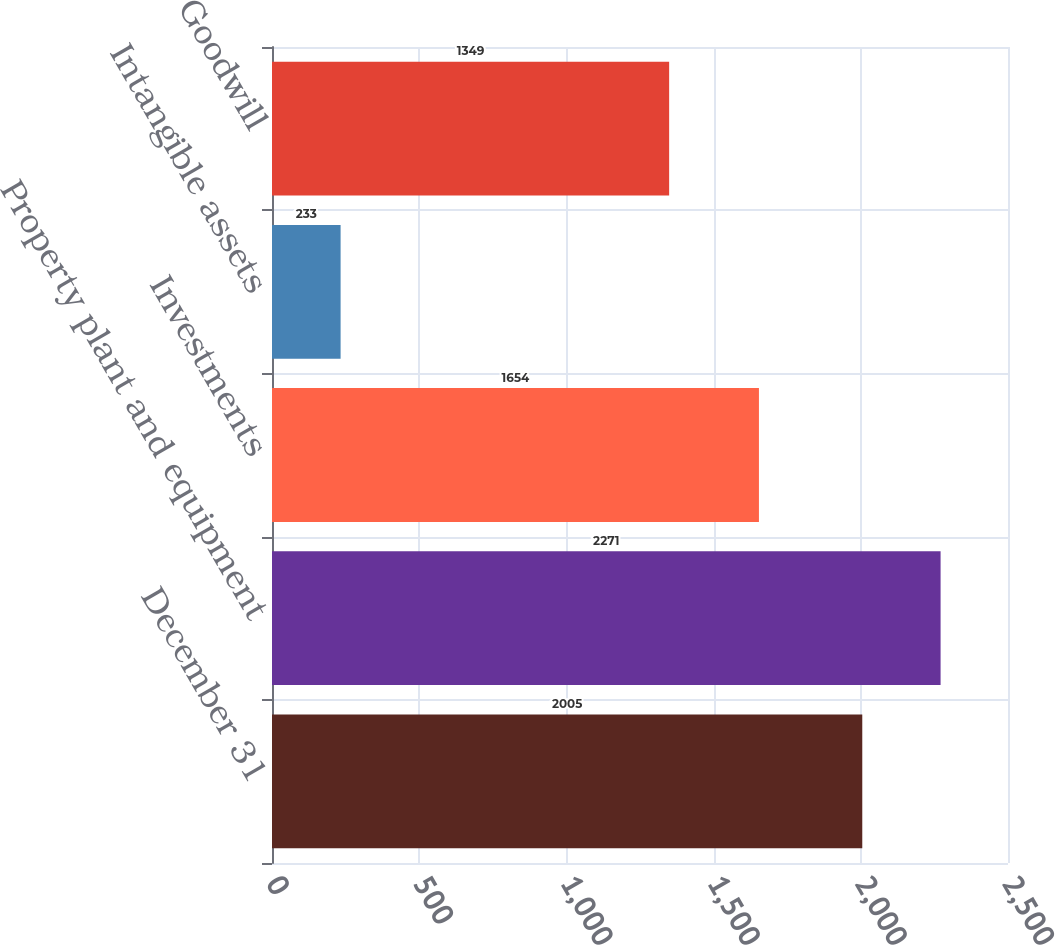<chart> <loc_0><loc_0><loc_500><loc_500><bar_chart><fcel>December 31<fcel>Property plant and equipment<fcel>Investments<fcel>Intangible assets<fcel>Goodwill<nl><fcel>2005<fcel>2271<fcel>1654<fcel>233<fcel>1349<nl></chart> 